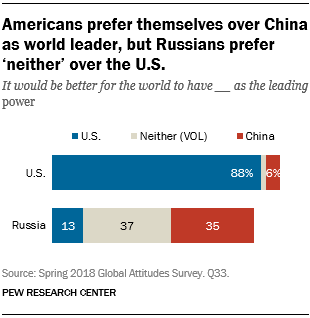List a handful of essential elements in this visual. The ratio between the blue bars 88 and 13 is approximately 3.675694444... Find the Missing data is a process of identifying and filling in missing values in a dataset that spans numbers 13, 35, and 37. 